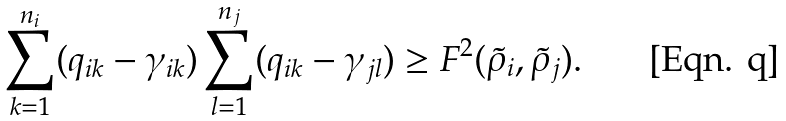Convert formula to latex. <formula><loc_0><loc_0><loc_500><loc_500>\sum _ { k = 1 } ^ { n _ { i } } ( q _ { i k } - \gamma _ { i k } ) \sum _ { l = 1 } ^ { n _ { j } } ( q _ { i k } - \gamma _ { j l } ) \geq F ^ { 2 } ( \tilde { \rho } _ { i } , \tilde { \rho } _ { j } ) .</formula> 